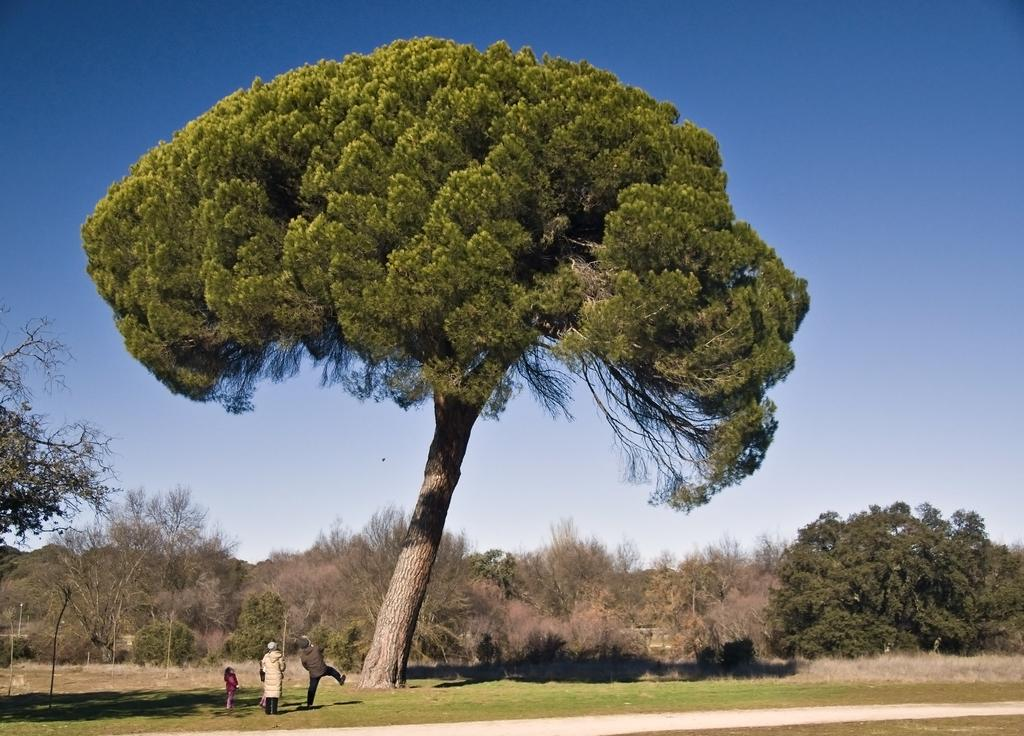How many kids are in the image? There are two kids in the image. What is the position of the person in the image? There is a person standing in the image. What is the other person doing in the image? There is another person in motion in the image. What can be seen on the ground in the image? The ground is visible in the image. What type of vegetation is present in the background of the image? There are trees and grass in the background of the image. What part of the natural environment is visible in the background of the image? The sky is visible in the background of the image. What type of rabbit can be seen hopping in the image? There is no rabbit present in the image; it features two kids, a standing person, and a person in motion. What advice does the dad give to the kids in the image? There is no dad present in the image, and therefore no advice can be given. 